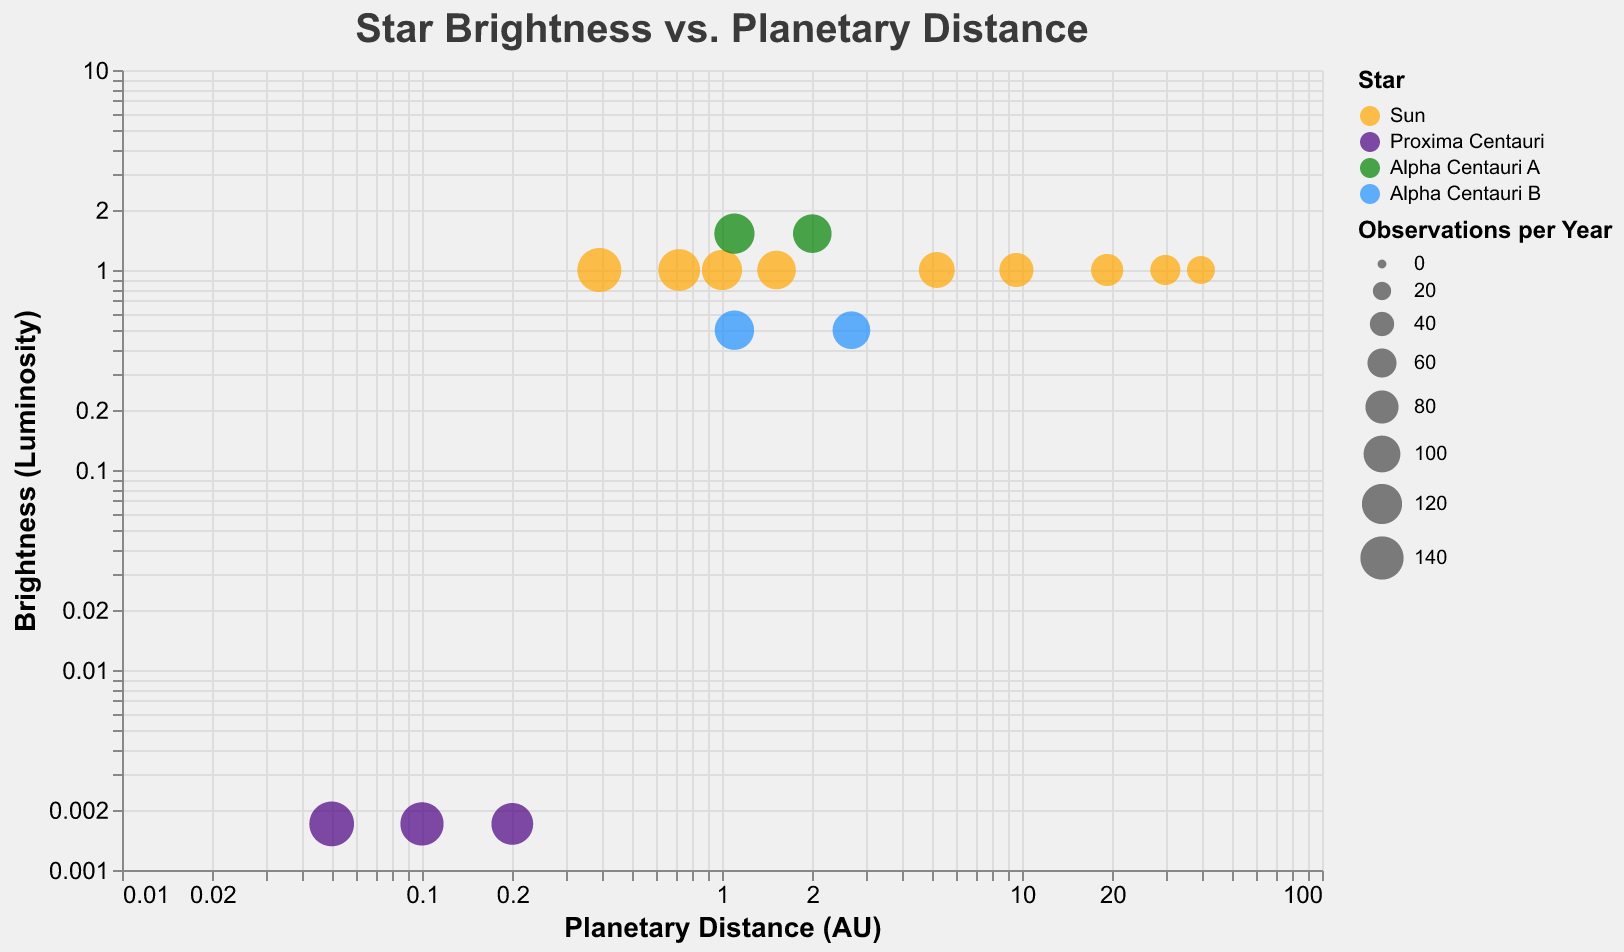When the distance from the star increases, what is the general trend in the frequency of observations? As the planetary distance (AU) increases on the x-axis, the size of the bubbles generally decreases, indicating a declining frequency of observations.
Answer: The frequency of observations decreases Which star has the most frequent observations for its closest planet? Proxima Centauri at a distance of 0.05 AU has a bubble with the largest size, indicating the highest observation frequency of 150 per year.
Answer: Proxima Centauri Which star appears to have planets at distances closest to the Sun's planetary distances? Observing the x-axis for planetary distance, Alpha Centauri A and Alpha Centauri B have planets at distances (1.10 AU and 2.00 AU for Alpha Centauri A; 1.10 AU and 2.70 AU for Alpha Centauri B) that are close to those of the Sun's planets.
Answer: Alpha Centauri A and Alpha Centauri B How does the brightness of Alpha Centauri A compare to that of the other stars? Alpha Centauri A has a brightness (luminosity) of 1.52, which is higher than the Sun (1.00) and Alpha Centauri B (0.50). Proxima Centauri has a very low brightness of 0.0017.
Answer: Alpha Centauri A is the brightest Which planet orbits the Sun at the greatest distance and what is its frequency of observations? The planet orbiting the Sun at the greatest distance is at 39.48 AU, with a frequency of observations of 55 per year.
Answer: 39.48 AU, 55 observations Compare the frequencies of observations for planets at 1.10 AU around different stars. The bubble sizes at 1.10 AU show the following frequencies: Alpha Centauri A (120), Alpha Centauri B (115), and the Sun has no listed planet at this distance.
Answer: Alpha Centauri A: 120, Alpha Centauri B: 115 What is the relationship between star brightness and the frequency of observations for nearby planets? Generally, brighter stars like the Sun and Alpha Centauri A have high frequencies of observations for nearby planets, but the low brightness of Proxima Centauri also has a high frequency due to close distances.
Answer: Higher brightness often correlates with higher observation frequency for nearby planets For which star do we have the fewest data points? By counting the bubbles per star, Proxima Centauri has 3 data points, which is the fewest.
Answer: Proxima Centauri How does the frequency of observations change for planets around Proxima Centauri as the distance increases? For Proxima Centauri, as the planetary distance increases from 0.05 AU to 0.10 AU to 0.20 AU, the frequency of observations decreases from 150 to 140 to 130 per year, respectively.
Answer: The frequency decreases What is the common trait of stars with the highest and lowest planetary distances measured in the data? Both stars with the highest (39.48 AU for the Sun) and the lowest (0.05 AU for Proxima Centauri) planetary distances have a relatively high number of observations in their range, although the frequency is higher for the closest planet.
Answer: High observation frequency 